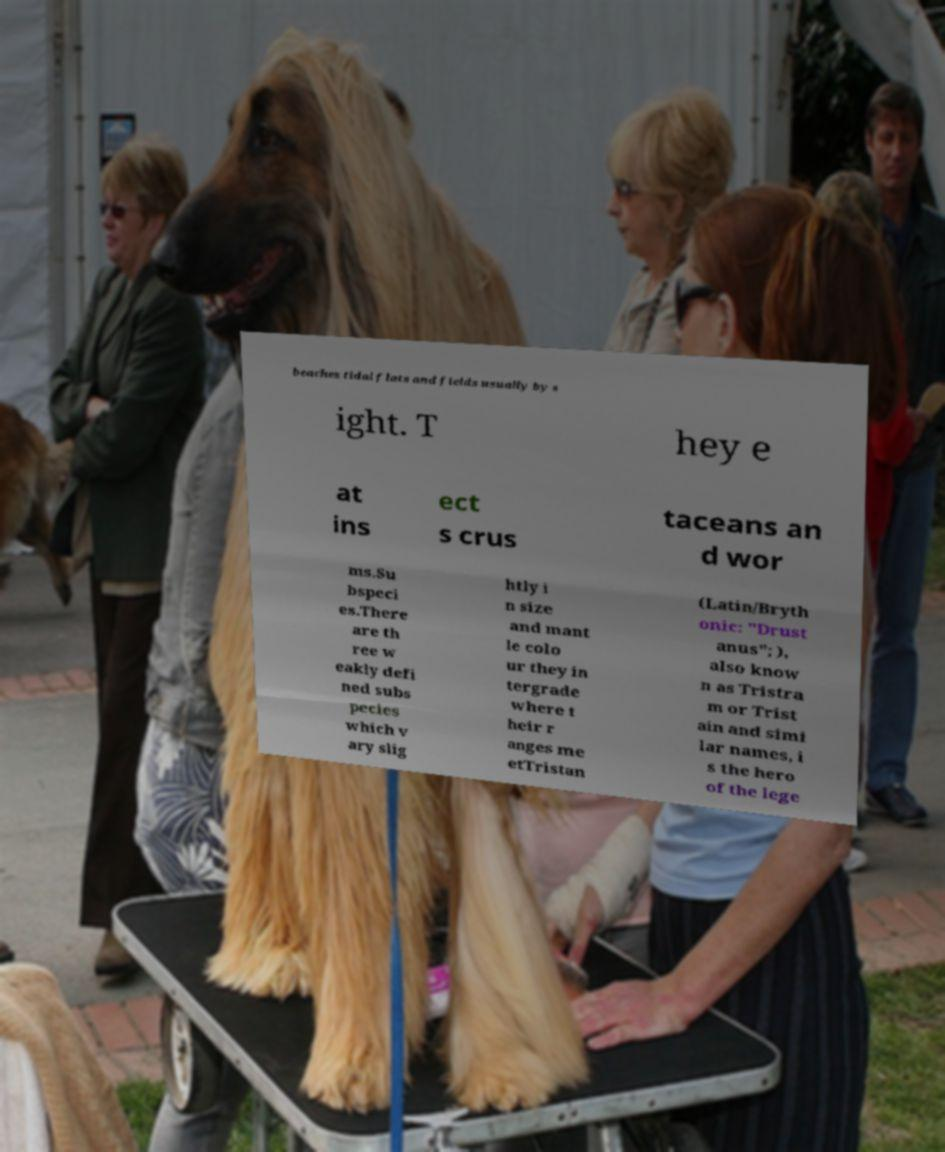Please read and relay the text visible in this image. What does it say? beaches tidal flats and fields usually by s ight. T hey e at ins ect s crus taceans an d wor ms.Su bspeci es.There are th ree w eakly defi ned subs pecies which v ary slig htly i n size and mant le colo ur they in tergrade where t heir r anges me etTristan (Latin/Bryth onic: "Drust anus"; ), also know n as Tristra m or Trist ain and simi lar names, i s the hero of the lege 